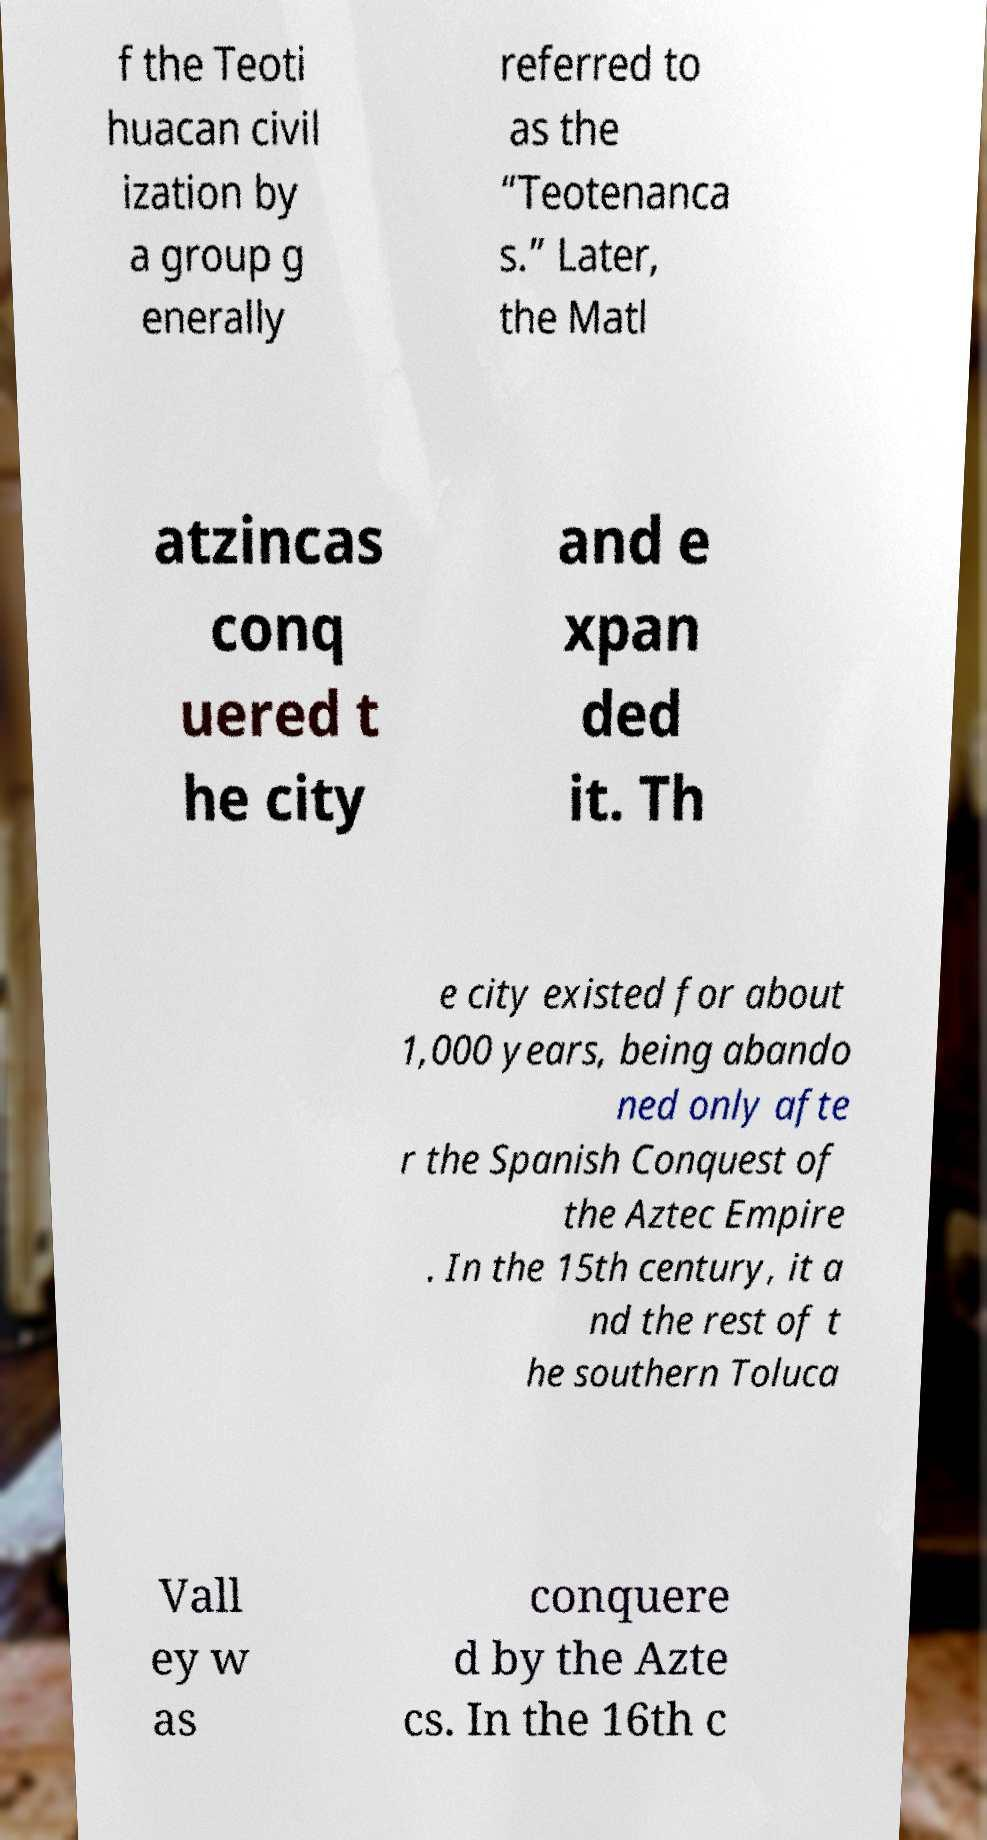Please read and relay the text visible in this image. What does it say? f the Teoti huacan civil ization by a group g enerally referred to as the “Teotenanca s.” Later, the Matl atzincas conq uered t he city and e xpan ded it. Th e city existed for about 1,000 years, being abando ned only afte r the Spanish Conquest of the Aztec Empire . In the 15th century, it a nd the rest of t he southern Toluca Vall ey w as conquere d by the Azte cs. In the 16th c 